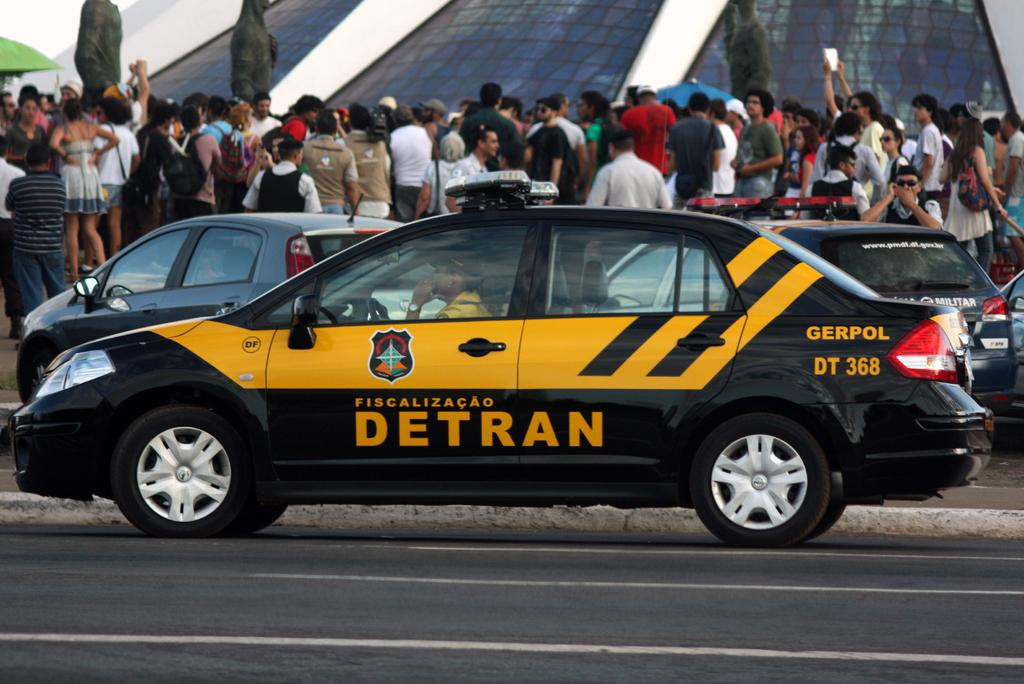<image>
Summarize the visual content of the image. Black and yellow car that says fiscalizacao detran 